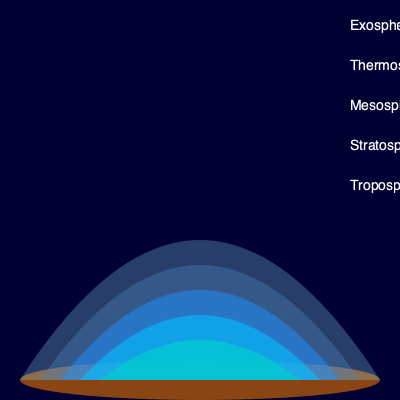In the diagram of Earth's atmosphere, which layer is characterized by the ozone layer and temperature inversion, and how does this affect its properties? To answer this question, let's examine the layers of Earth's atmosphere from bottom to top:

1. Troposphere: The lowest layer where most weather phenomena occur.

2. Stratosphere: This is the layer we're focusing on. It has two key characteristics:
   a) Ozone Layer: Located in the lower stratosphere, it absorbs harmful UV radiation.
   b) Temperature Inversion: Unlike the troposphere, temperature increases with altitude.

3. Mesosphere: Temperature decreases with height, and it's the coldest layer.

4. Thermosphere: Temperature increases dramatically due to absorption of solar radiation.

5. Exosphere: The outermost layer, transitioning to space.

The stratosphere's unique properties affect it in several ways:

1. The ozone layer absorbs UV radiation, which:
   a) Protects life on Earth from harmful radiation
   b) Causes the temperature inversion

2. The temperature inversion:
   a) Creates a stable layer with little vertical mixing
   b) Prevents most weather phenomena from penetrating higher
   c) Allows for smooth air travel as there's less turbulence

3. These properties combined make the stratosphere ideal for:
   a) Long-distance air travel
   b) Weather balloon observations
   c) Some types of atmospheric research

The presence of the ozone layer and temperature inversion in the stratosphere significantly influences its stability, radiation absorption, and suitability for various atmospheric and human activities.
Answer: Stratosphere; ozone absorption and temperature inversion create stability and protection. 